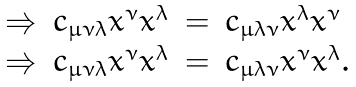Convert formula to latex. <formula><loc_0><loc_0><loc_500><loc_500>\begin{array} { r r c l } \Rightarrow & c _ { \mu \nu \lambda } x ^ { \nu } x ^ { \lambda } & = & c _ { \mu \lambda \nu } x ^ { \lambda } x ^ { \nu } \\ \Rightarrow & c _ { \mu \nu \lambda } x ^ { \nu } x ^ { \lambda } & = & c _ { \mu \lambda \nu } x ^ { \nu } x ^ { \lambda } . \end{array}</formula> 